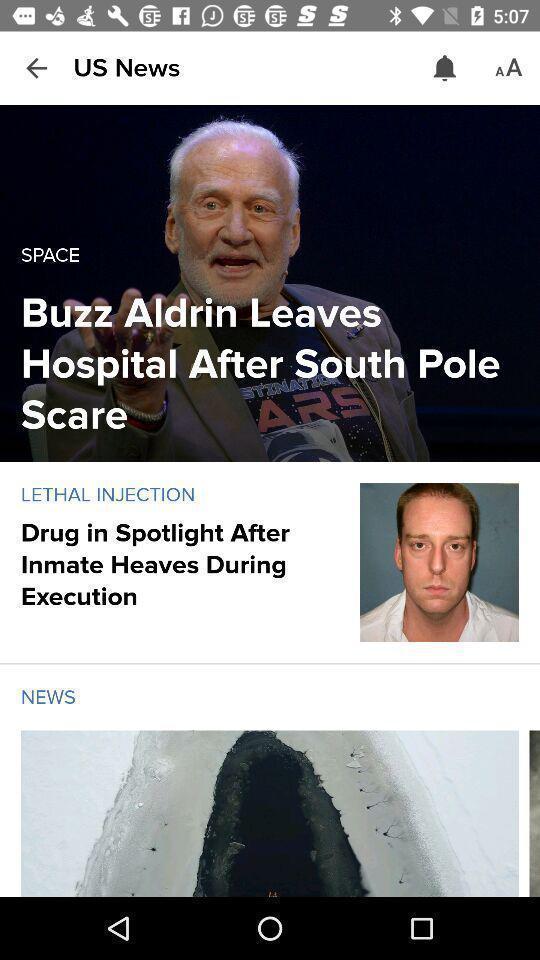Summarize the main components in this picture. Screen showing the thumbnails in news app. 